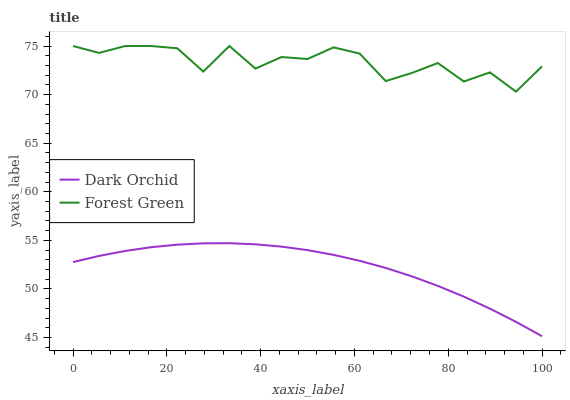Does Dark Orchid have the maximum area under the curve?
Answer yes or no. No. Is Dark Orchid the roughest?
Answer yes or no. No. Does Dark Orchid have the highest value?
Answer yes or no. No. Is Dark Orchid less than Forest Green?
Answer yes or no. Yes. Is Forest Green greater than Dark Orchid?
Answer yes or no. Yes. Does Dark Orchid intersect Forest Green?
Answer yes or no. No. 